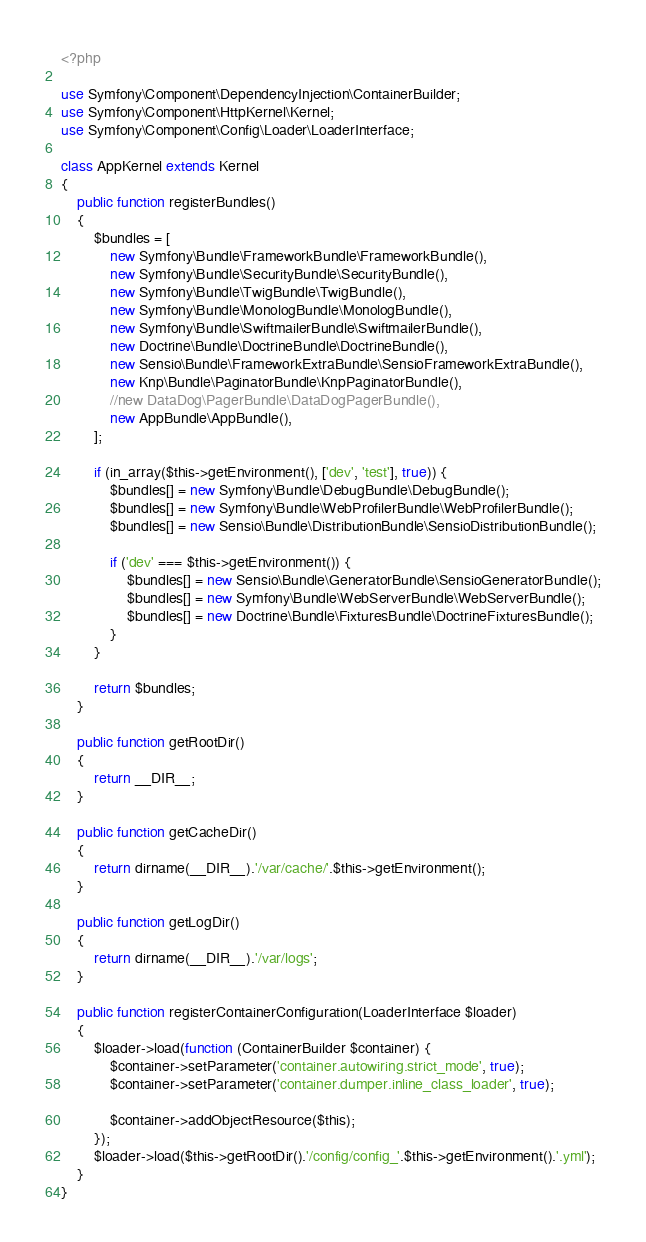Convert code to text. <code><loc_0><loc_0><loc_500><loc_500><_PHP_><?php

use Symfony\Component\DependencyInjection\ContainerBuilder;
use Symfony\Component\HttpKernel\Kernel;
use Symfony\Component\Config\Loader\LoaderInterface;

class AppKernel extends Kernel
{
    public function registerBundles()
    {
        $bundles = [
            new Symfony\Bundle\FrameworkBundle\FrameworkBundle(),
            new Symfony\Bundle\SecurityBundle\SecurityBundle(),
            new Symfony\Bundle\TwigBundle\TwigBundle(),
            new Symfony\Bundle\MonologBundle\MonologBundle(),
            new Symfony\Bundle\SwiftmailerBundle\SwiftmailerBundle(),
            new Doctrine\Bundle\DoctrineBundle\DoctrineBundle(),
            new Sensio\Bundle\FrameworkExtraBundle\SensioFrameworkExtraBundle(),
			new Knp\Bundle\PaginatorBundle\KnpPaginatorBundle(),
			//new DataDog\PagerBundle\DataDogPagerBundle(),
            new AppBundle\AppBundle(),
        ];

        if (in_array($this->getEnvironment(), ['dev', 'test'], true)) {
            $bundles[] = new Symfony\Bundle\DebugBundle\DebugBundle();
            $bundles[] = new Symfony\Bundle\WebProfilerBundle\WebProfilerBundle();
            $bundles[] = new Sensio\Bundle\DistributionBundle\SensioDistributionBundle();

            if ('dev' === $this->getEnvironment()) {
                $bundles[] = new Sensio\Bundle\GeneratorBundle\SensioGeneratorBundle();
                $bundles[] = new Symfony\Bundle\WebServerBundle\WebServerBundle();
				$bundles[] = new Doctrine\Bundle\FixturesBundle\DoctrineFixturesBundle();
            }
        }

        return $bundles;
    }

    public function getRootDir()
    {
        return __DIR__;
    }

    public function getCacheDir()
    {
        return dirname(__DIR__).'/var/cache/'.$this->getEnvironment();
    }

    public function getLogDir()
    {
        return dirname(__DIR__).'/var/logs';
    }

    public function registerContainerConfiguration(LoaderInterface $loader)
    {
        $loader->load(function (ContainerBuilder $container) {
            $container->setParameter('container.autowiring.strict_mode', true);
            $container->setParameter('container.dumper.inline_class_loader', true);

            $container->addObjectResource($this);
        });
        $loader->load($this->getRootDir().'/config/config_'.$this->getEnvironment().'.yml');
    }
}
</code> 